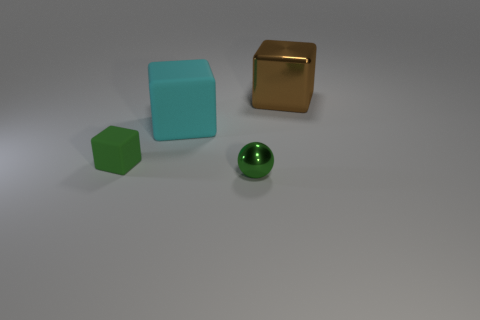What number of objects are large yellow rubber objects or big cyan rubber blocks that are to the left of the sphere?
Give a very brief answer. 1. There is a thing that is behind the green sphere and in front of the cyan object; what color is it?
Make the answer very short. Green. Do the green matte block and the brown metal object have the same size?
Your response must be concise. No. What color is the large thing that is on the left side of the tiny green sphere?
Make the answer very short. Cyan. Are there any tiny balls that have the same color as the big rubber cube?
Make the answer very short. No. What is the color of the matte object that is the same size as the brown metallic block?
Make the answer very short. Cyan. Is the shape of the brown shiny thing the same as the big cyan matte object?
Make the answer very short. Yes. There is a big object in front of the large brown metallic cube; what material is it?
Your answer should be very brief. Rubber. The large matte thing is what color?
Your answer should be very brief. Cyan. There is a shiny thing that is in front of the brown shiny object; is its size the same as the green object that is behind the tiny green metallic sphere?
Your answer should be compact. Yes. 